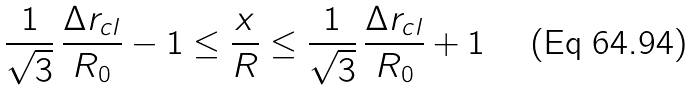<formula> <loc_0><loc_0><loc_500><loc_500>\frac { 1 } { \sqrt { 3 } } \, \frac { \Delta r _ { c l } } { R _ { 0 } } - 1 \leq \frac { x } { R } \leq \frac { 1 } { \sqrt { 3 } } \, \frac { \Delta r _ { c l } } { R _ { 0 } } + 1</formula> 